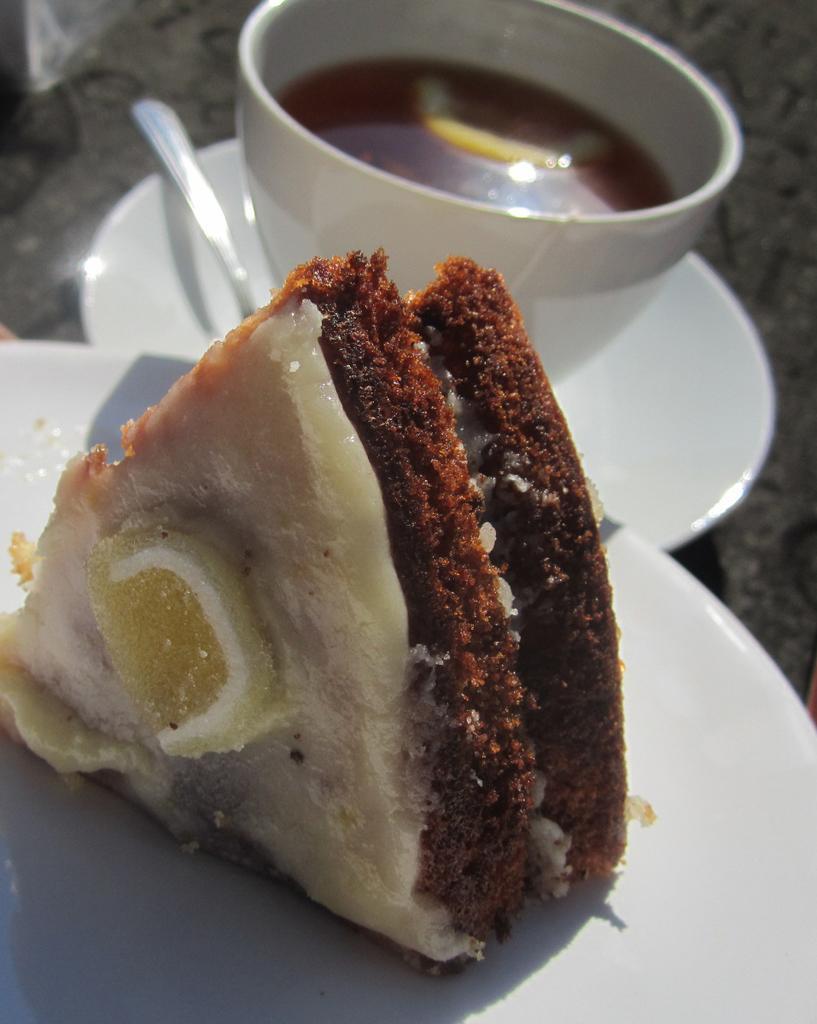In one or two sentences, can you explain what this image depicts? In this image in the foreground there is one plate, on the plate there is one pastry and in the background there is one cup, saucer and spoon. In the cup there is some drink. 